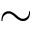<formula> <loc_0><loc_0><loc_500><loc_500>\sim</formula> 